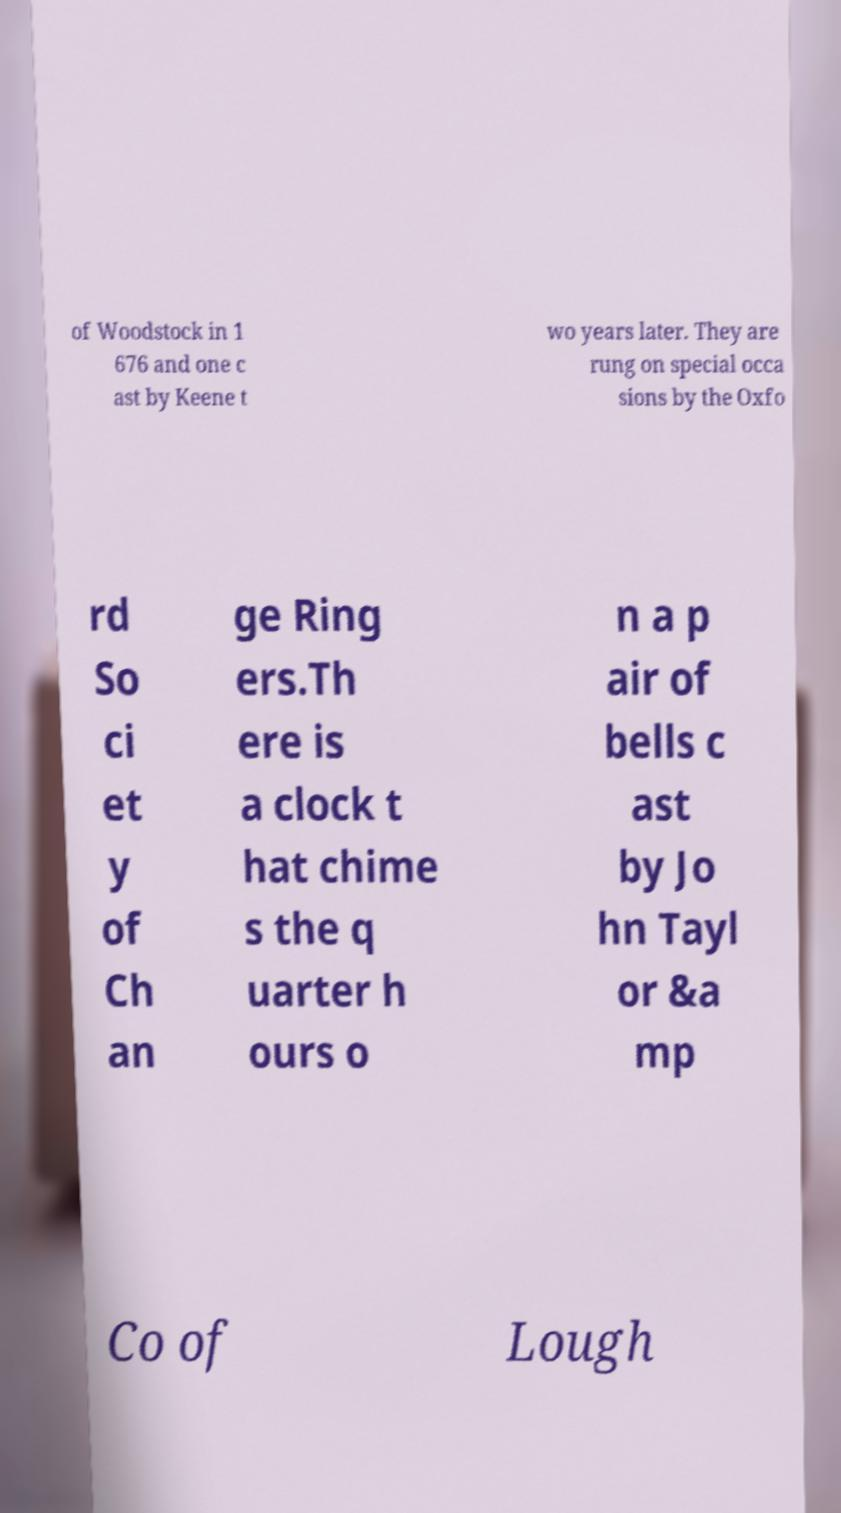Can you read and provide the text displayed in the image?This photo seems to have some interesting text. Can you extract and type it out for me? of Woodstock in 1 676 and one c ast by Keene t wo years later. They are rung on special occa sions by the Oxfo rd So ci et y of Ch an ge Ring ers.Th ere is a clock t hat chime s the q uarter h ours o n a p air of bells c ast by Jo hn Tayl or &a mp Co of Lough 